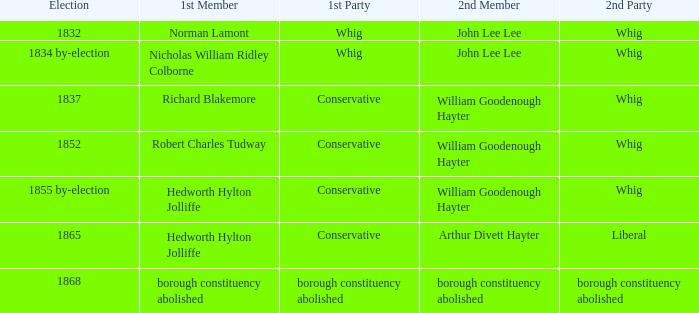What's the party of 2nd member arthur divett hayter when the 1st party is conservative? Liberal. 